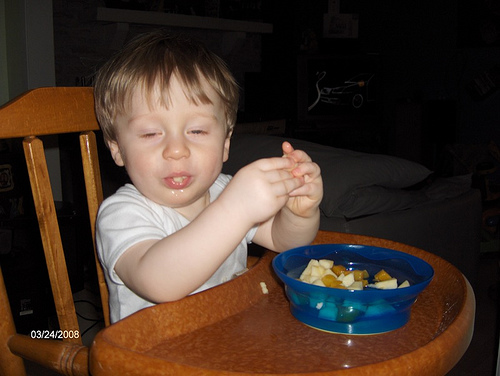<image>
Is there a bowl on the chair? Yes. Looking at the image, I can see the bowl is positioned on top of the chair, with the chair providing support. 